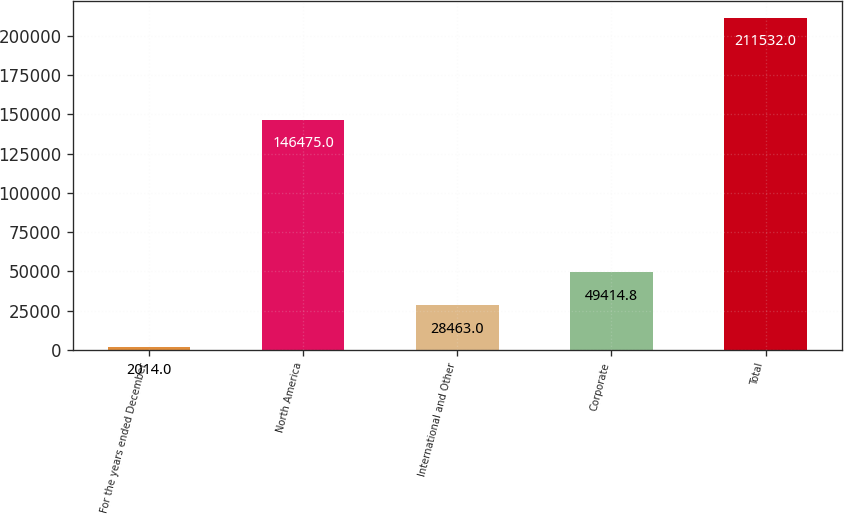Convert chart to OTSL. <chart><loc_0><loc_0><loc_500><loc_500><bar_chart><fcel>For the years ended December<fcel>North America<fcel>International and Other<fcel>Corporate<fcel>Total<nl><fcel>2014<fcel>146475<fcel>28463<fcel>49414.8<fcel>211532<nl></chart> 